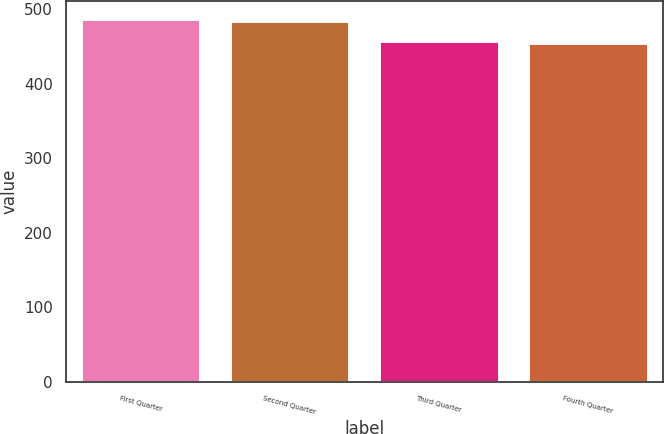<chart> <loc_0><loc_0><loc_500><loc_500><bar_chart><fcel>First Quarter<fcel>Second Quarter<fcel>Third Quarter<fcel>Fourth Quarter<nl><fcel>487.52<fcel>483.78<fcel>458.13<fcel>454.86<nl></chart> 